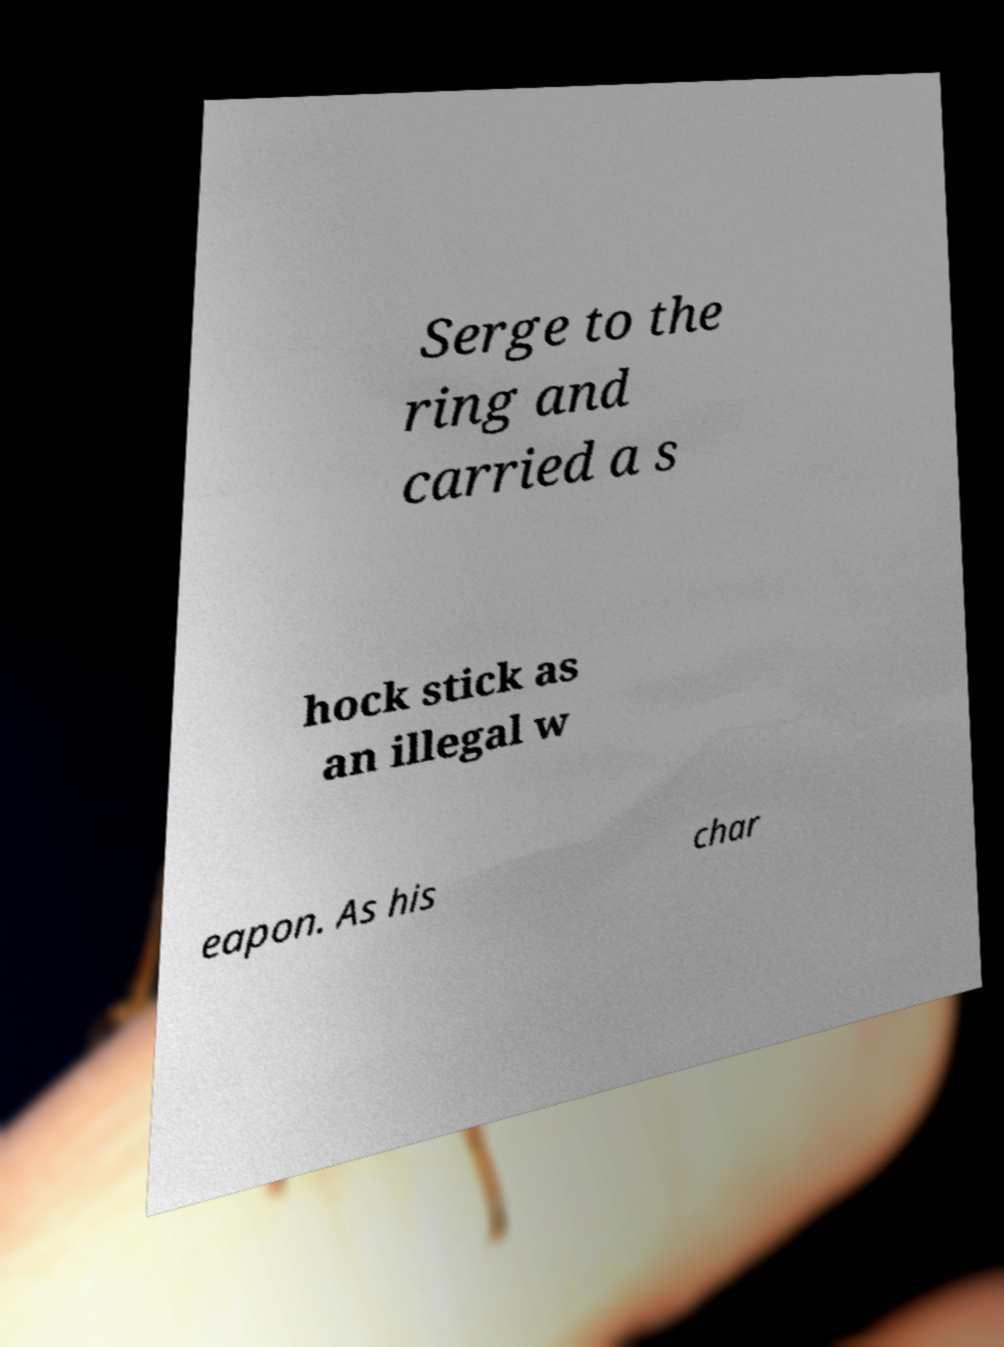Could you extract and type out the text from this image? Serge to the ring and carried a s hock stick as an illegal w eapon. As his char 